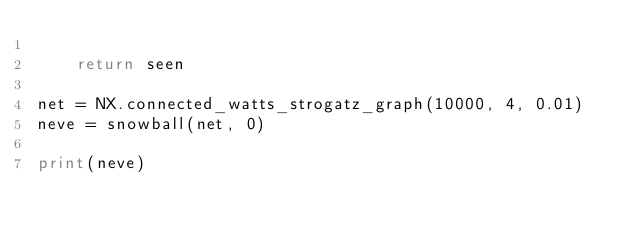<code> <loc_0><loc_0><loc_500><loc_500><_Python_>
    return seen

net = NX.connected_watts_strogatz_graph(10000, 4, 0.01)
neve = snowball(net, 0)

print(neve)
</code> 